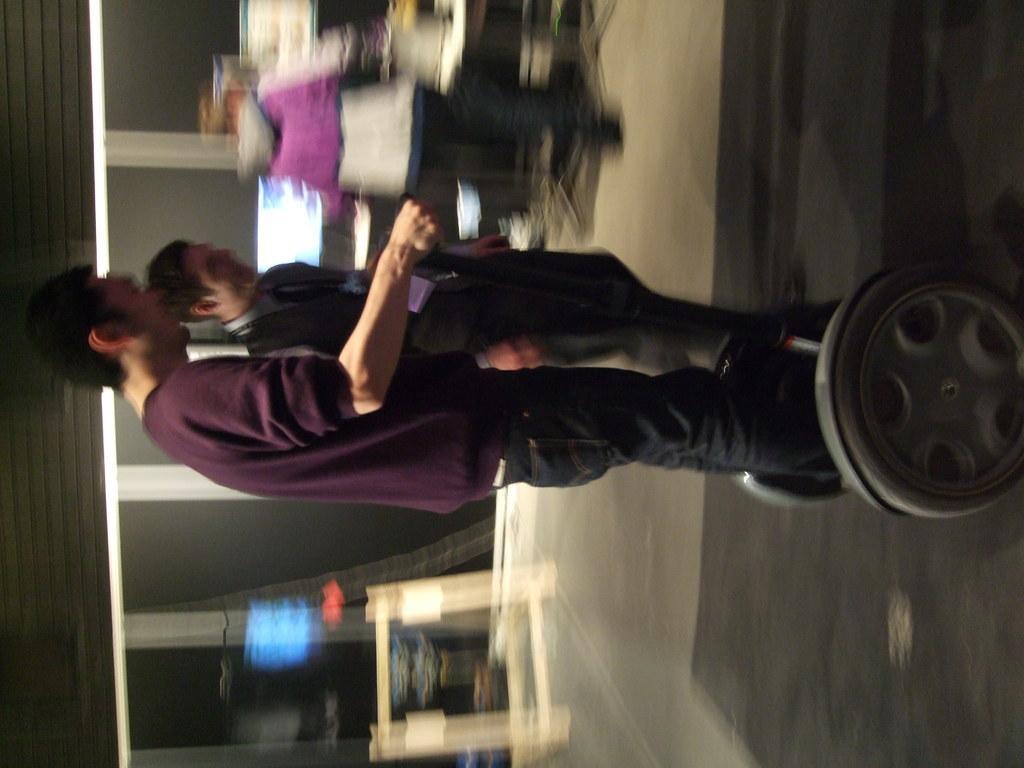Describe this image in one or two sentences. In the center of the image two persons are standing. On the right side of the image we can see wheels, floor are there. On the left side of the image we can see wall, lights are there. 